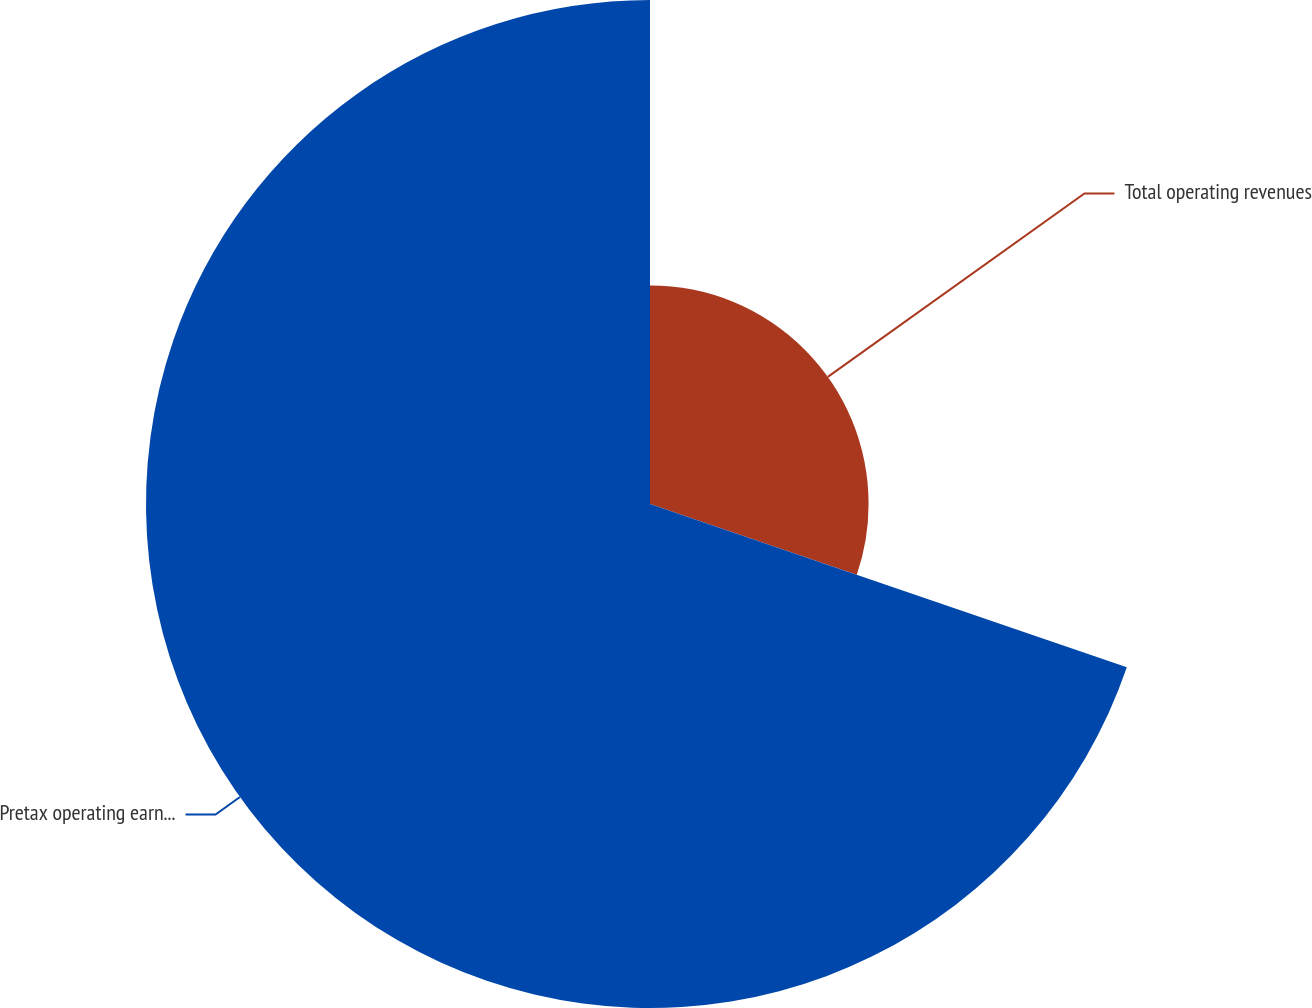Convert chart. <chart><loc_0><loc_0><loc_500><loc_500><pie_chart><fcel>Total operating revenues<fcel>Pretax operating earnings<nl><fcel>30.25%<fcel>69.75%<nl></chart> 